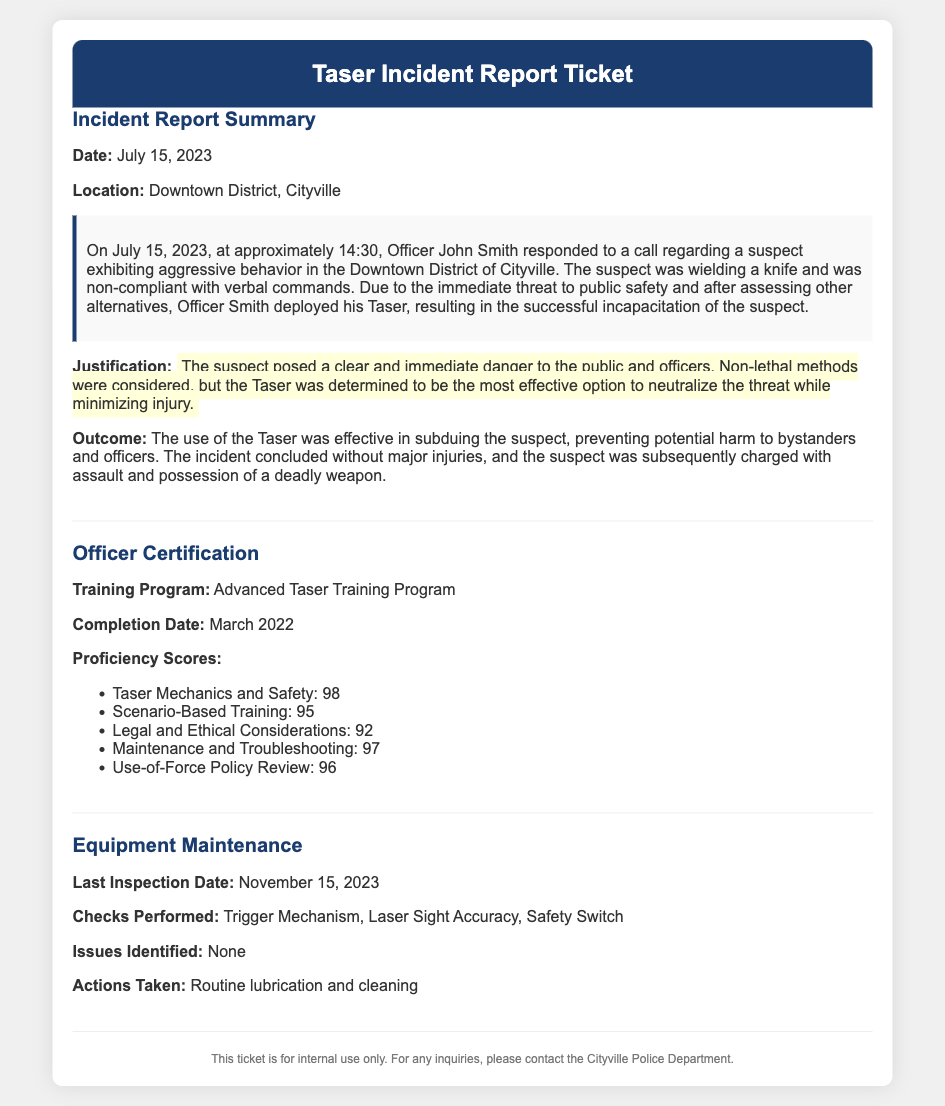what date did the incident occur? The date of the incident is specified at the beginning of the incident report summary section.
Answer: July 15, 2023 what was the location of the incident? The location of the incident is given in the incident report summary section.
Answer: Downtown District, Cityville who responded to the call? The name of the officer who responded to the call is mentioned in the incident report summary.
Answer: Officer John Smith what was the proficiency score in Taser Mechanics and Safety? The score for Taser Mechanics and Safety is listed under officer certification.
Answer: 98 what was identified as a potential issue during the last maintenance check? The issues identified during the equipment maintenance section are specifically noted.
Answer: None why was the Taser deemed the most effective option? The justification for Taser deployment provides the reasoning for choosing the Taser over other methods.
Answer: Immediate danger what trainings were covered in the Taser training program? The modules covered are specified in the officer certification section.
Answer: Mechanics and Safety, Scenario-Based Training, Legal and Ethical Considerations, Maintenance and Troubleshooting, Use-of-Force Policy Review what was the last inspection date for the equipment? The last inspection date is mentioned in the equipment maintenance section.
Answer: November 15, 2023 what is the outcome of the incident? The outcome is detailed at the end of the incident report summary section.
Answer: No major injuries, suspect charged 